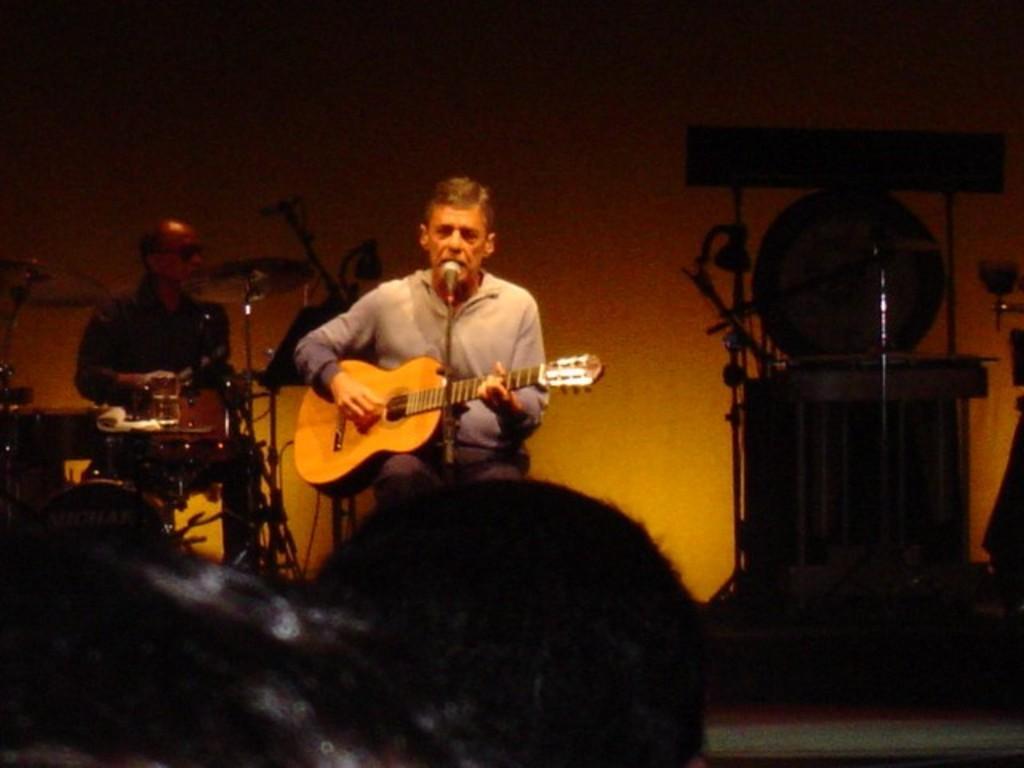How would you summarize this image in a sentence or two? In this picture i could see a person sitting and holding a guitar in his hands in the back ground i could see other person and beating on drums and there are some other instruments in the right side of the picture and i could see the left corner a person's head. 